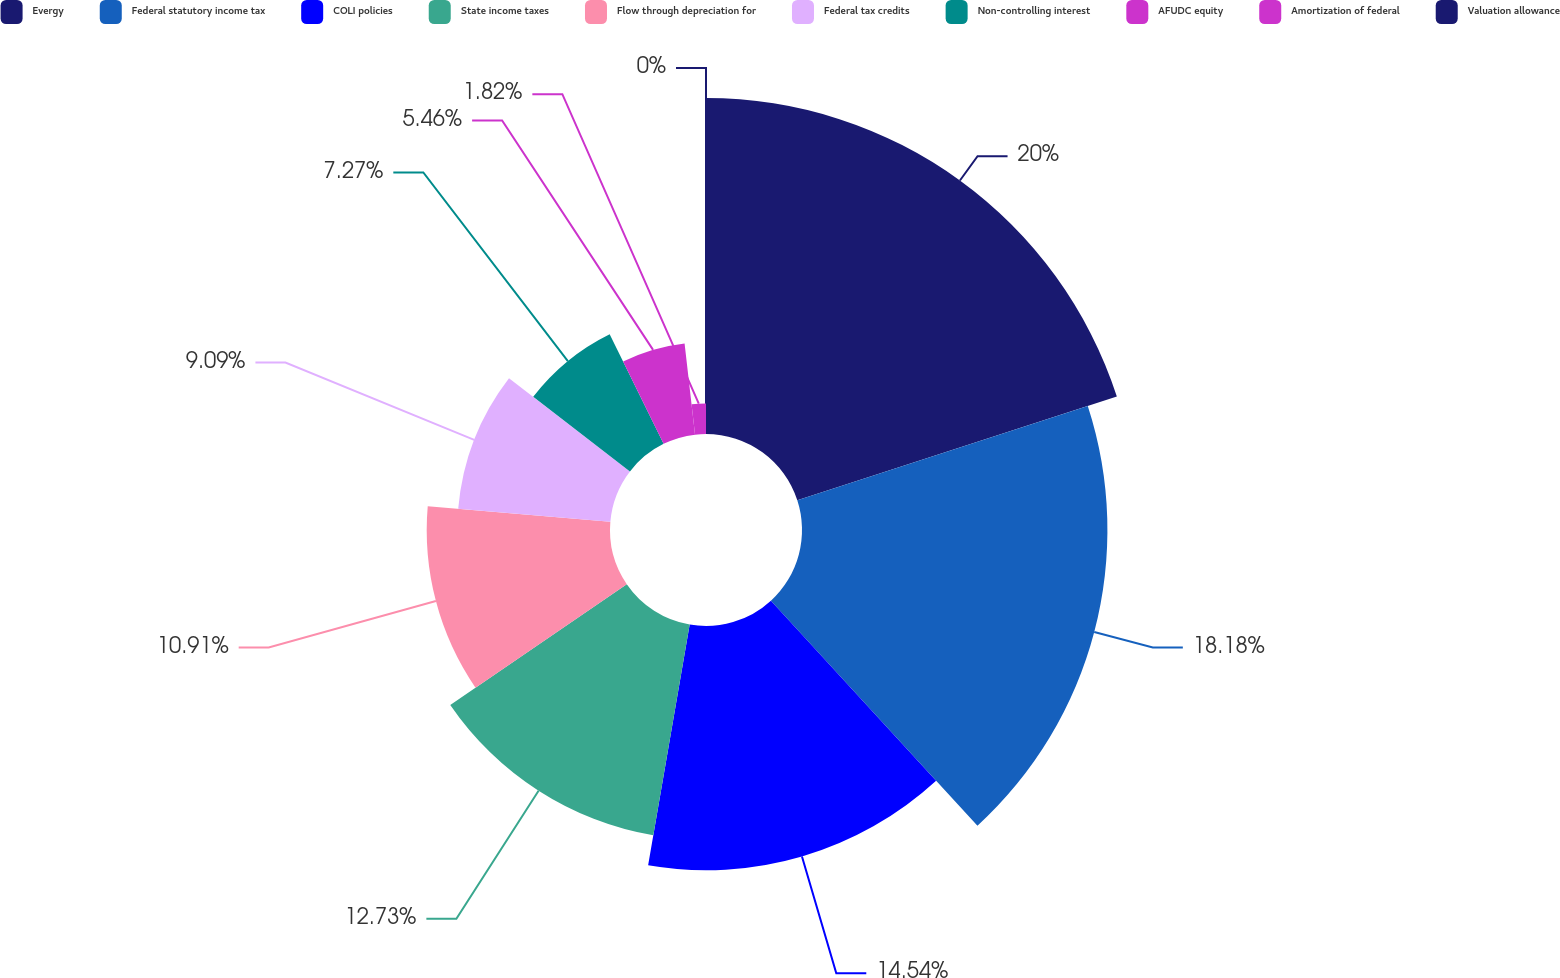<chart> <loc_0><loc_0><loc_500><loc_500><pie_chart><fcel>Evergy<fcel>Federal statutory income tax<fcel>COLI policies<fcel>State income taxes<fcel>Flow through depreciation for<fcel>Federal tax credits<fcel>Non-controlling interest<fcel>AFUDC equity<fcel>Amortization of federal<fcel>Valuation allowance<nl><fcel>20.0%<fcel>18.18%<fcel>14.54%<fcel>12.73%<fcel>10.91%<fcel>9.09%<fcel>7.27%<fcel>5.46%<fcel>1.82%<fcel>0.0%<nl></chart> 